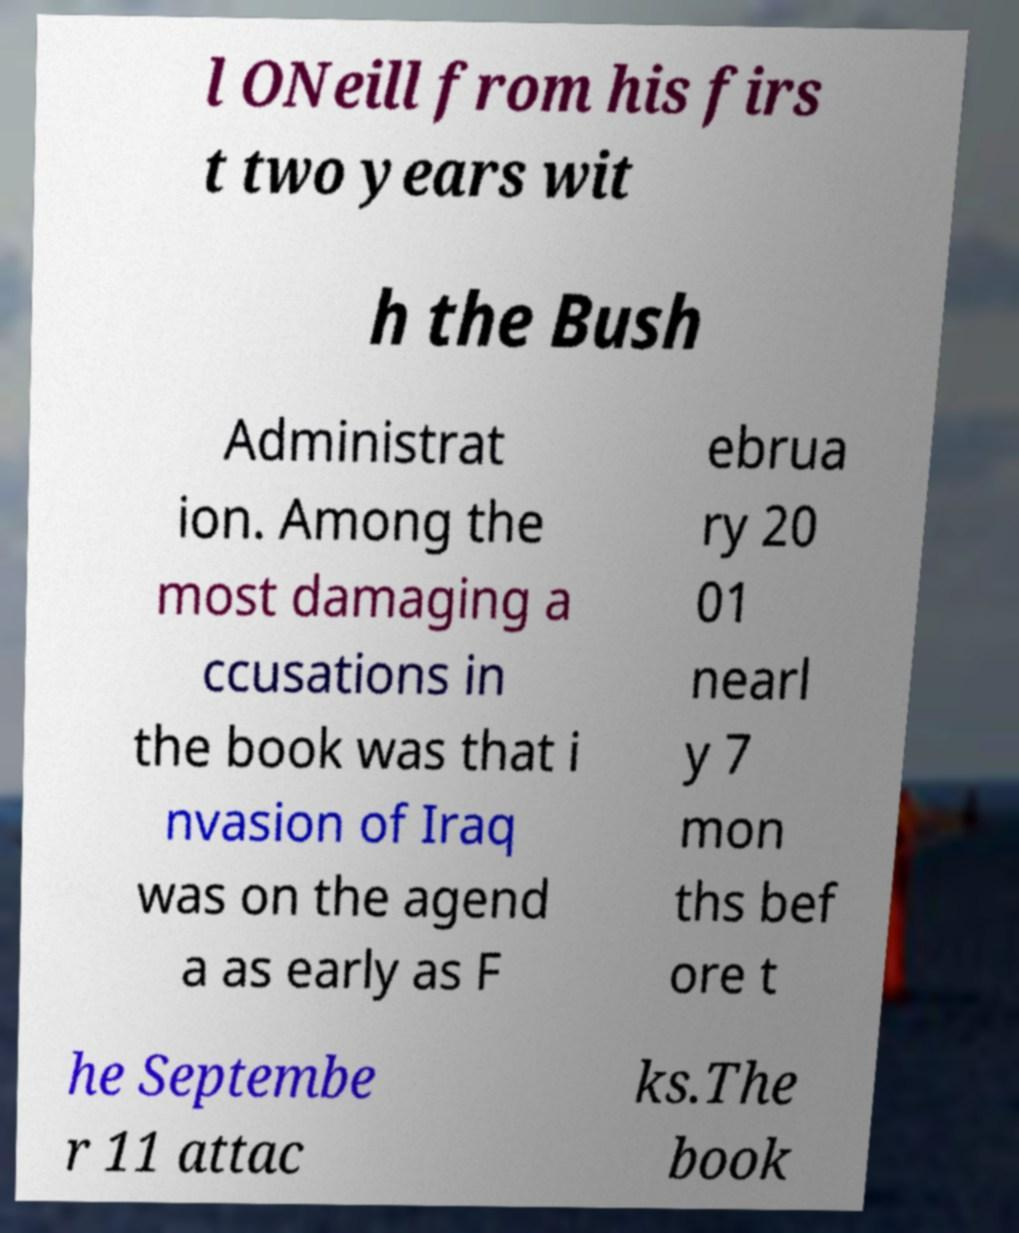Please identify and transcribe the text found in this image. l ONeill from his firs t two years wit h the Bush Administrat ion. Among the most damaging a ccusations in the book was that i nvasion of Iraq was on the agend a as early as F ebrua ry 20 01 nearl y 7 mon ths bef ore t he Septembe r 11 attac ks.The book 